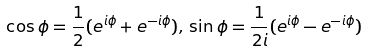Convert formula to latex. <formula><loc_0><loc_0><loc_500><loc_500>\cos \phi = \frac { 1 } { 2 } ( e ^ { i \phi } + e ^ { - i \phi } ) , \, \sin \phi = \frac { 1 } { 2 i } ( e ^ { i \phi } - e ^ { - i \phi } )</formula> 